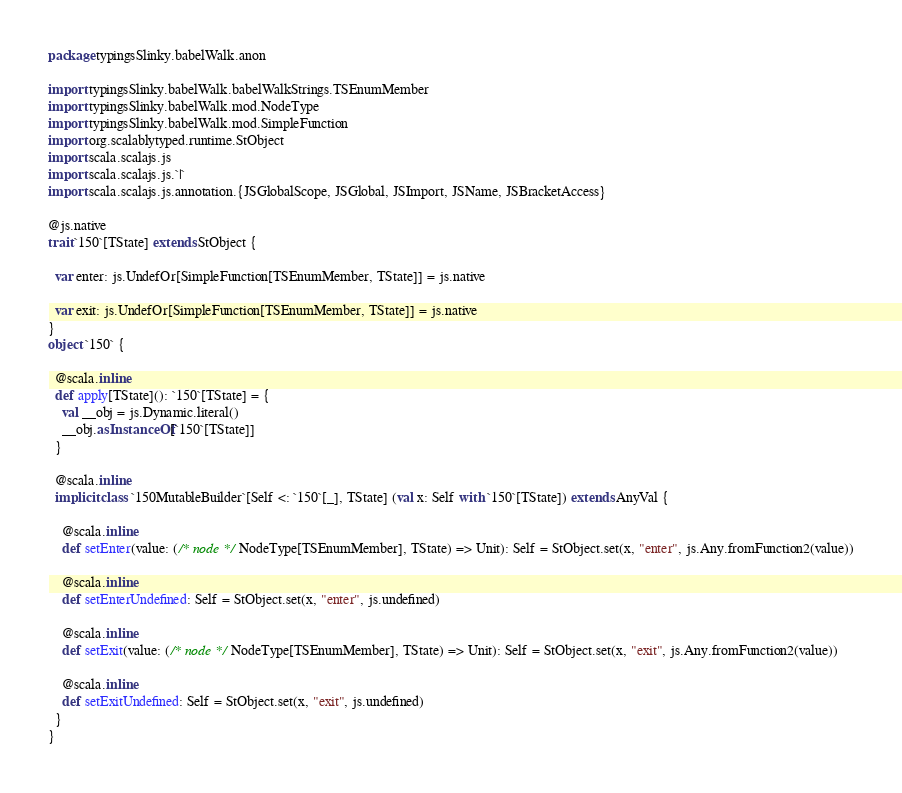<code> <loc_0><loc_0><loc_500><loc_500><_Scala_>package typingsSlinky.babelWalk.anon

import typingsSlinky.babelWalk.babelWalkStrings.TSEnumMember
import typingsSlinky.babelWalk.mod.NodeType
import typingsSlinky.babelWalk.mod.SimpleFunction
import org.scalablytyped.runtime.StObject
import scala.scalajs.js
import scala.scalajs.js.`|`
import scala.scalajs.js.annotation.{JSGlobalScope, JSGlobal, JSImport, JSName, JSBracketAccess}

@js.native
trait `150`[TState] extends StObject {
  
  var enter: js.UndefOr[SimpleFunction[TSEnumMember, TState]] = js.native
  
  var exit: js.UndefOr[SimpleFunction[TSEnumMember, TState]] = js.native
}
object `150` {
  
  @scala.inline
  def apply[TState](): `150`[TState] = {
    val __obj = js.Dynamic.literal()
    __obj.asInstanceOf[`150`[TState]]
  }
  
  @scala.inline
  implicit class `150MutableBuilder`[Self <: `150`[_], TState] (val x: Self with `150`[TState]) extends AnyVal {
    
    @scala.inline
    def setEnter(value: (/* node */ NodeType[TSEnumMember], TState) => Unit): Self = StObject.set(x, "enter", js.Any.fromFunction2(value))
    
    @scala.inline
    def setEnterUndefined: Self = StObject.set(x, "enter", js.undefined)
    
    @scala.inline
    def setExit(value: (/* node */ NodeType[TSEnumMember], TState) => Unit): Self = StObject.set(x, "exit", js.Any.fromFunction2(value))
    
    @scala.inline
    def setExitUndefined: Self = StObject.set(x, "exit", js.undefined)
  }
}
</code> 